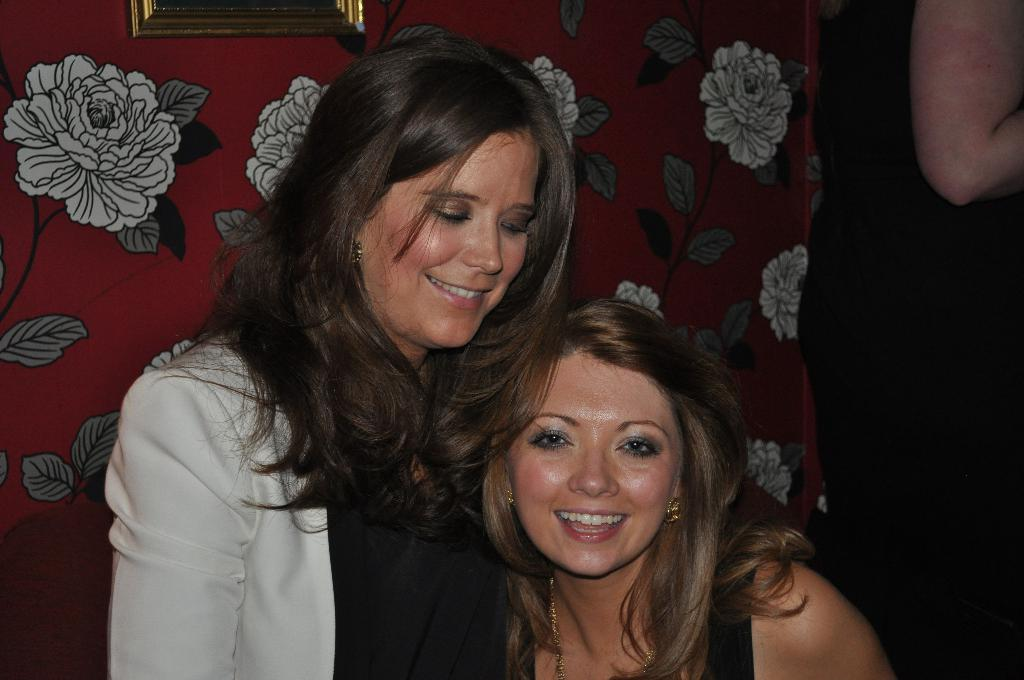What are the two ladies in the foreground of the image doing? The two ladies in the foreground of the image are smoking. Can you describe the lady in the background of the image? There is another lady in the background of the image, but no specific details are provided. What is on the wall in the image? There is a frame placed on the wall in the image. How does the family interact with the railway in the image? There is no railway present in the image, so it is not possible to answer that question. 